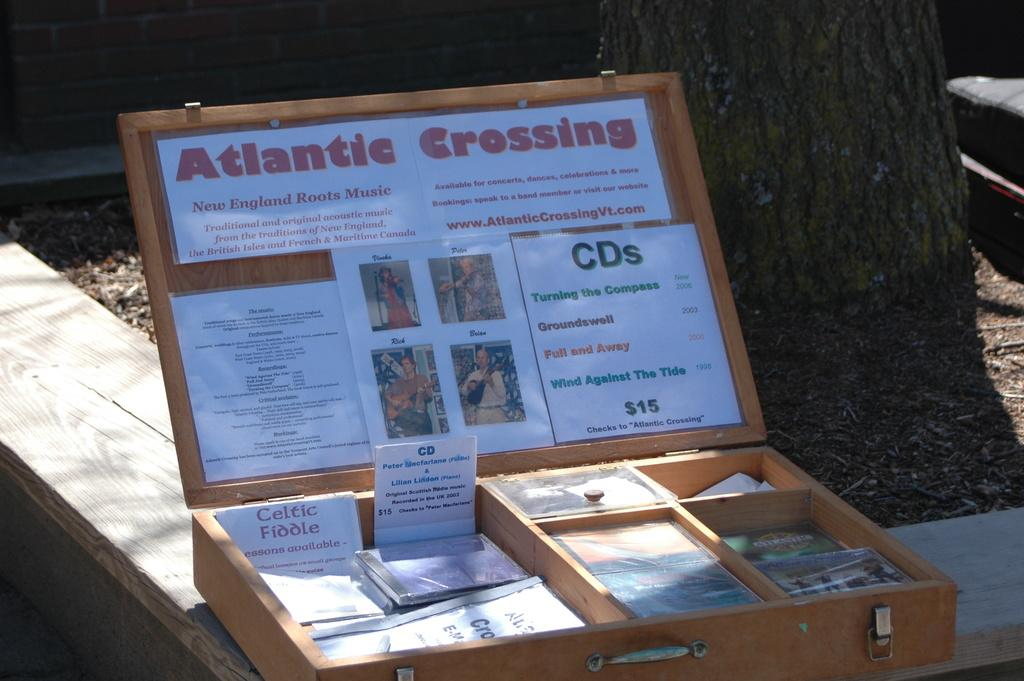<image>
Give a short and clear explanation of the subsequent image. A wooden box with Atlantic Crossing in red letters on it. 